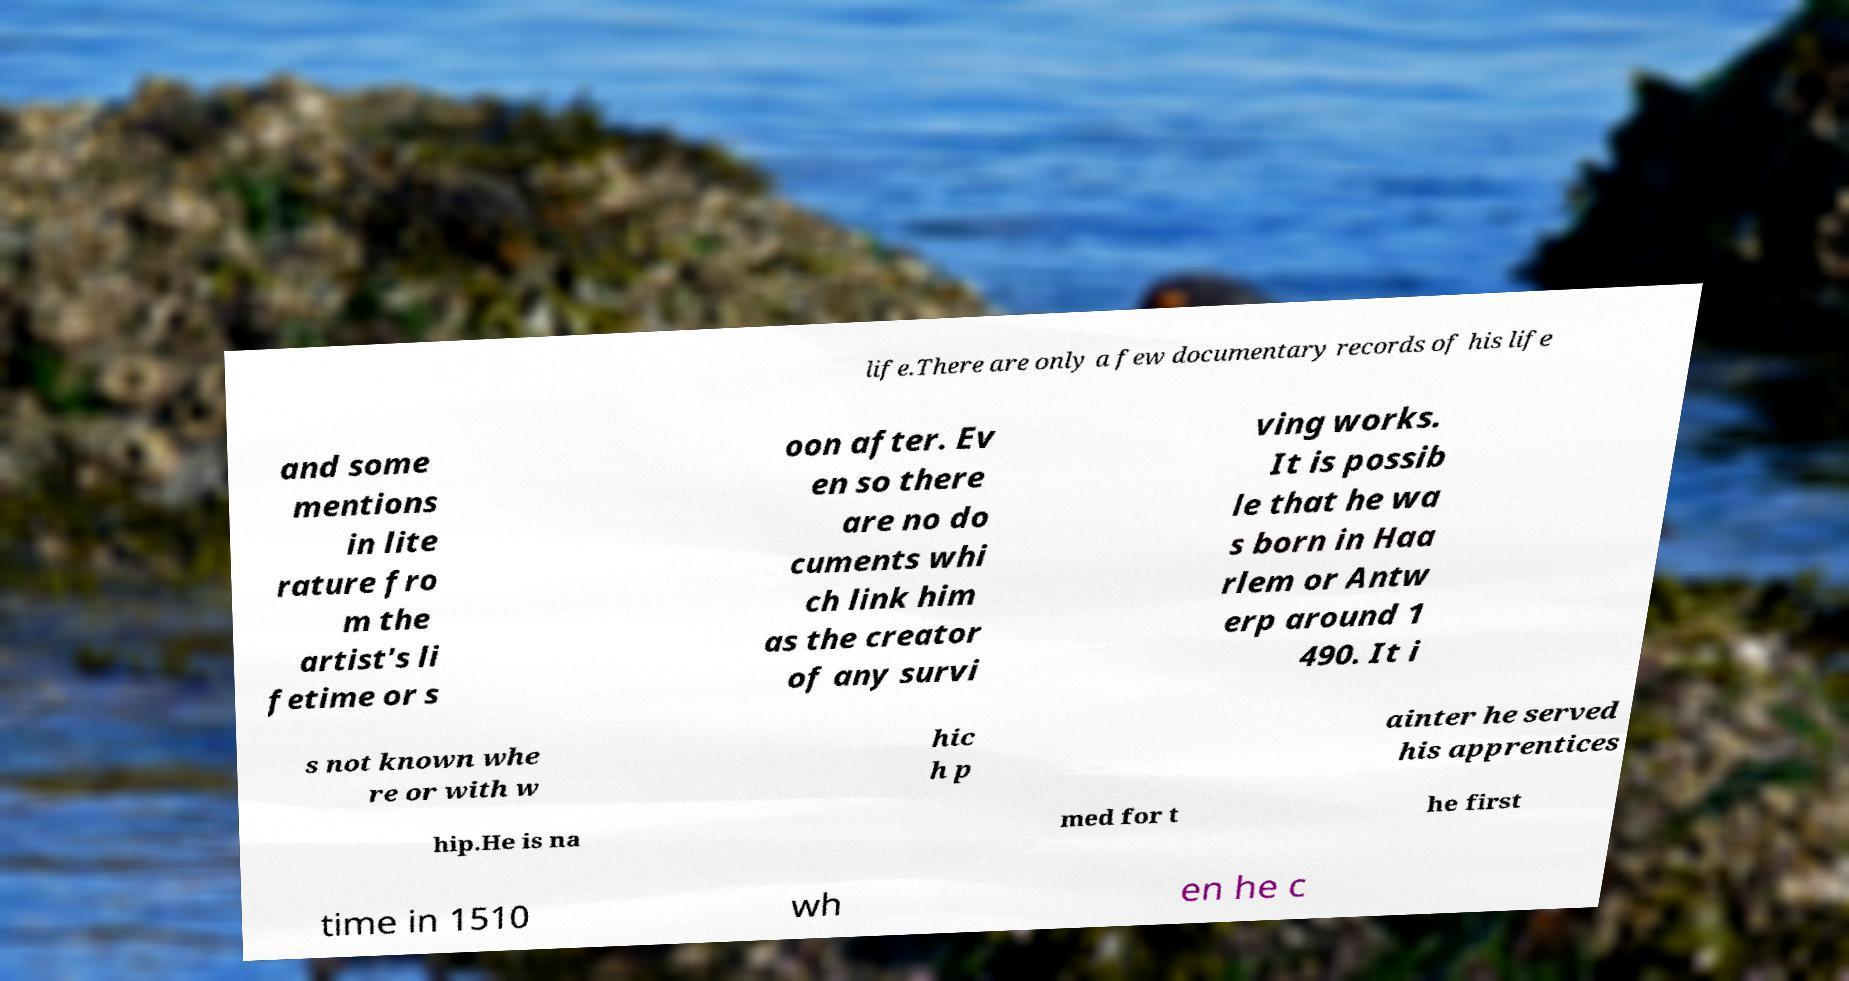Please read and relay the text visible in this image. What does it say? life.There are only a few documentary records of his life and some mentions in lite rature fro m the artist's li fetime or s oon after. Ev en so there are no do cuments whi ch link him as the creator of any survi ving works. It is possib le that he wa s born in Haa rlem or Antw erp around 1 490. It i s not known whe re or with w hic h p ainter he served his apprentices hip.He is na med for t he first time in 1510 wh en he c 